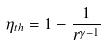Convert formula to latex. <formula><loc_0><loc_0><loc_500><loc_500>\eta _ { t h } = 1 - \frac { 1 } { r ^ { \gamma - 1 } }</formula> 